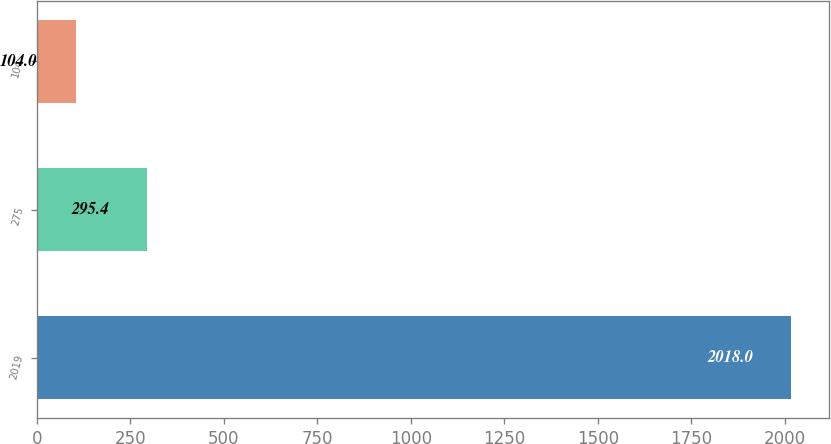Convert chart to OTSL. <chart><loc_0><loc_0><loc_500><loc_500><bar_chart><fcel>2019<fcel>275<fcel>104<nl><fcel>2018<fcel>295.4<fcel>104<nl></chart> 